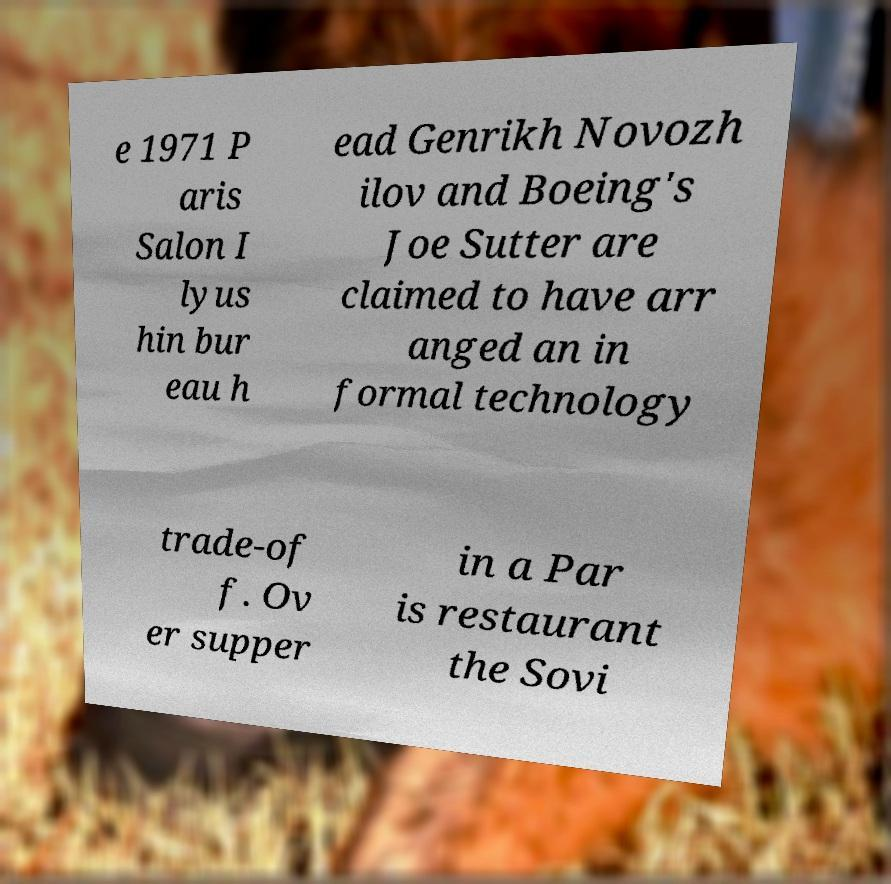For documentation purposes, I need the text within this image transcribed. Could you provide that? e 1971 P aris Salon I lyus hin bur eau h ead Genrikh Novozh ilov and Boeing's Joe Sutter are claimed to have arr anged an in formal technology trade-of f. Ov er supper in a Par is restaurant the Sovi 